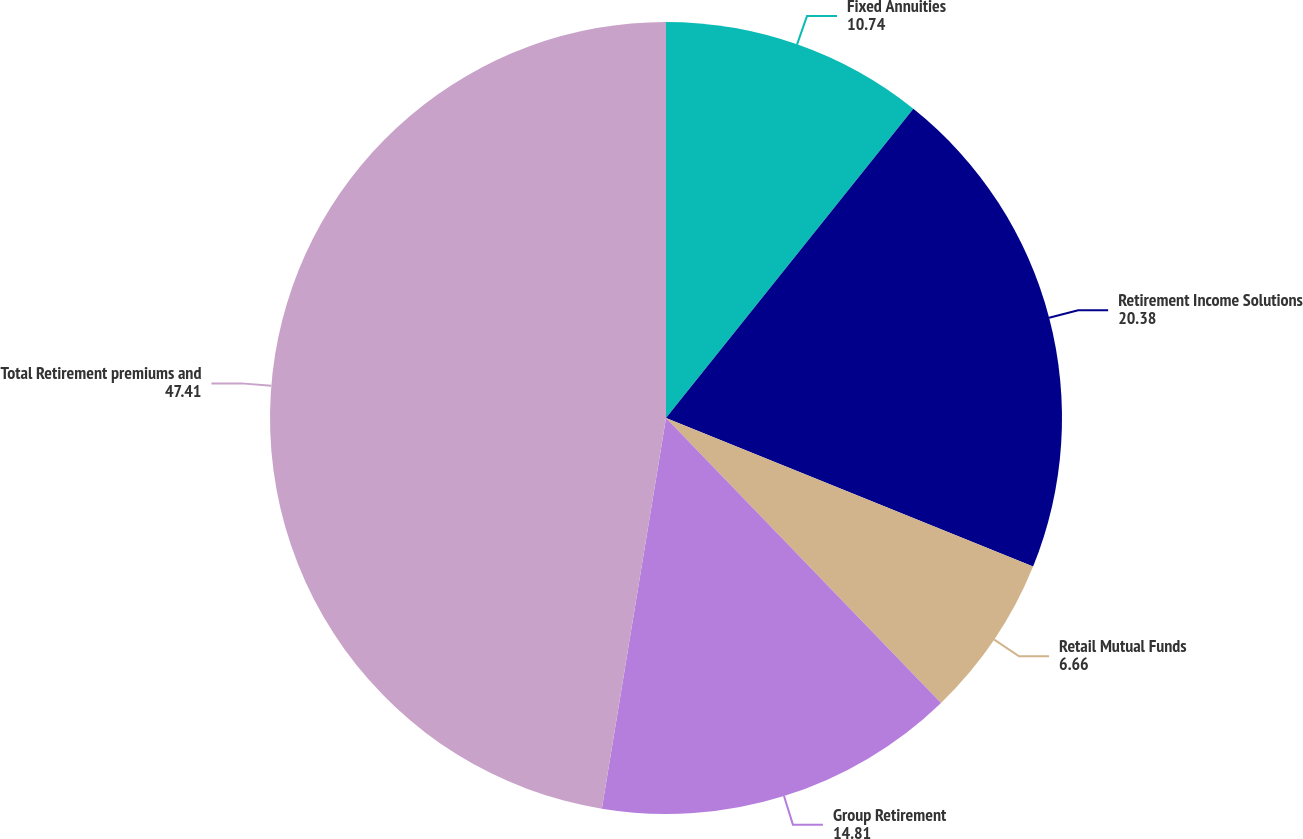Convert chart. <chart><loc_0><loc_0><loc_500><loc_500><pie_chart><fcel>Fixed Annuities<fcel>Retirement Income Solutions<fcel>Retail Mutual Funds<fcel>Group Retirement<fcel>Total Retirement premiums and<nl><fcel>10.74%<fcel>20.38%<fcel>6.66%<fcel>14.81%<fcel>47.41%<nl></chart> 